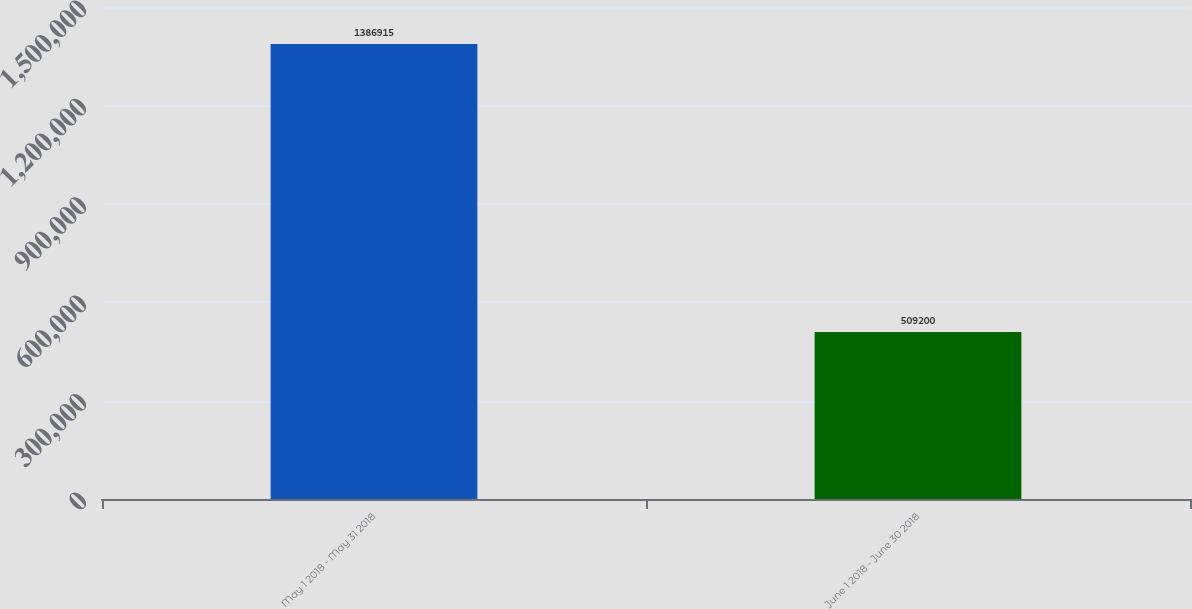Convert chart to OTSL. <chart><loc_0><loc_0><loc_500><loc_500><bar_chart><fcel>May 1 2018 - May 31 2018<fcel>June 1 2018 - June 30 2018<nl><fcel>1.38692e+06<fcel>509200<nl></chart> 